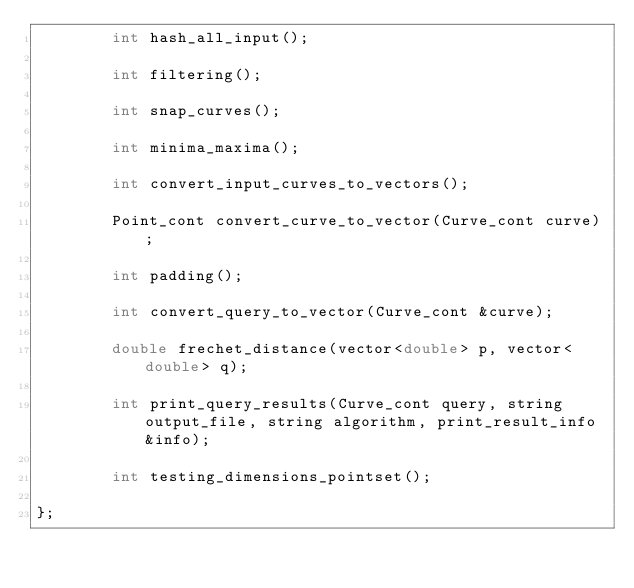Convert code to text. <code><loc_0><loc_0><loc_500><loc_500><_C++_>        int hash_all_input();

        int filtering();

        int snap_curves();

        int minima_maxima();

        int convert_input_curves_to_vectors();

        Point_cont convert_curve_to_vector(Curve_cont curve);

        int padding();

        int convert_query_to_vector(Curve_cont &curve);

        double frechet_distance(vector<double> p, vector<double> q);

        int print_query_results(Curve_cont query, string output_file, string algorithm, print_result_info &info);

        int testing_dimensions_pointset();

};</code> 